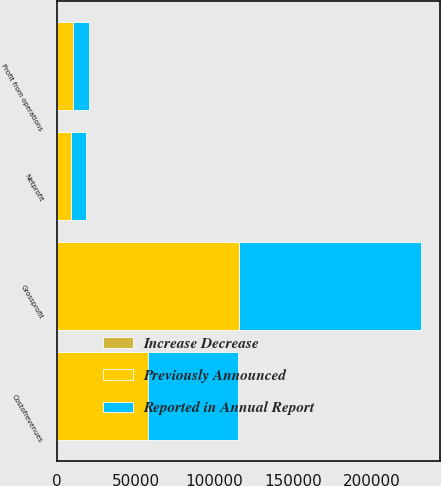Convert chart. <chart><loc_0><loc_0><loc_500><loc_500><stacked_bar_chart><ecel><fcel>Costofrevenues<fcel>Grossprofit<fcel>Profit from operations<fcel>Netprofit<nl><fcel>Reported in Annual Report<fcel>57143<fcel>115687<fcel>10148<fcel>9151<nl><fcel>Increase Decrease<fcel>383<fcel>383<fcel>383<fcel>383<nl><fcel>Previously Announced<fcel>57526<fcel>115304<fcel>9765<fcel>8768<nl></chart> 